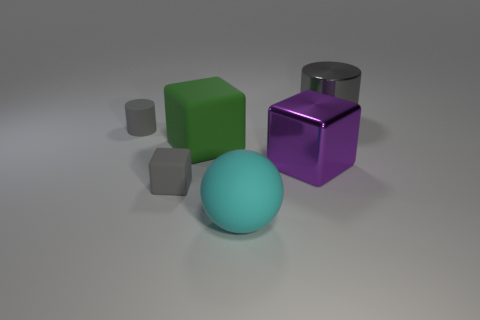Subtract all gray cylinders. How many were subtracted if there are1gray cylinders left? 1 Subtract all big green blocks. How many blocks are left? 2 Add 4 small gray matte spheres. How many objects exist? 10 Subtract all green cubes. How many cubes are left? 2 Subtract all brown cylinders. Subtract all yellow balls. How many cylinders are left? 2 Subtract all spheres. How many objects are left? 5 Subtract 2 cubes. How many cubes are left? 1 Add 4 red matte cubes. How many red matte cubes exist? 4 Subtract 0 red blocks. How many objects are left? 6 Subtract all large cyan rubber spheres. Subtract all purple cubes. How many objects are left? 4 